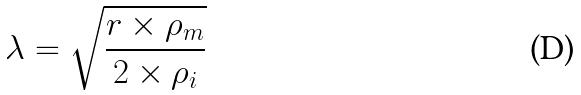<formula> <loc_0><loc_0><loc_500><loc_500>\lambda = \sqrt { \frac { r \times \rho _ { m } } { 2 \times \rho _ { i } } }</formula> 